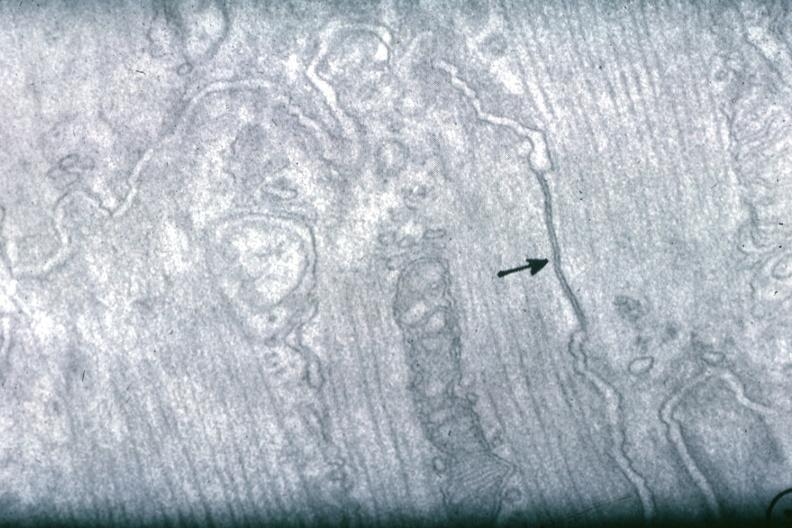where is this area in the body?
Answer the question using a single word or phrase. Heart 